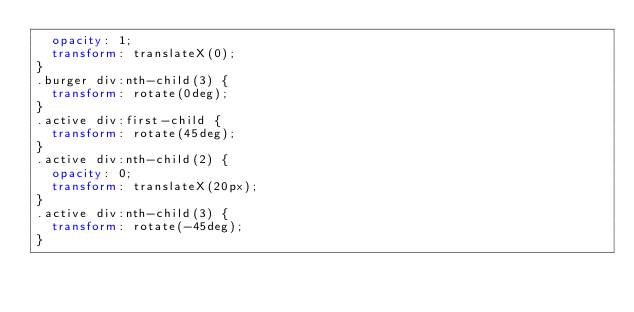Convert code to text. <code><loc_0><loc_0><loc_500><loc_500><_CSS_>  opacity: 1;
  transform: translateX(0);
}
.burger div:nth-child(3) {
  transform: rotate(0deg);
}
.active div:first-child {
  transform: rotate(45deg);
}
.active div:nth-child(2) {
  opacity: 0;
  transform: translateX(20px);
}
.active div:nth-child(3) {
  transform: rotate(-45deg);
}
</code> 